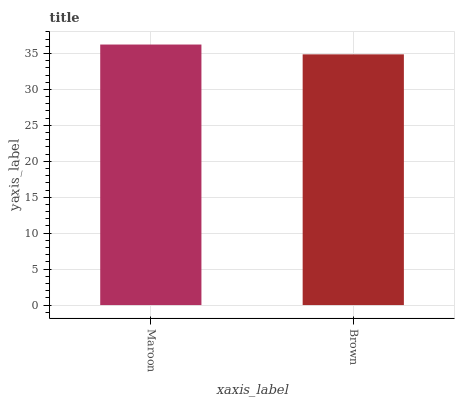Is Brown the maximum?
Answer yes or no. No. Is Maroon greater than Brown?
Answer yes or no. Yes. Is Brown less than Maroon?
Answer yes or no. Yes. Is Brown greater than Maroon?
Answer yes or no. No. Is Maroon less than Brown?
Answer yes or no. No. Is Maroon the high median?
Answer yes or no. Yes. Is Brown the low median?
Answer yes or no. Yes. Is Brown the high median?
Answer yes or no. No. Is Maroon the low median?
Answer yes or no. No. 